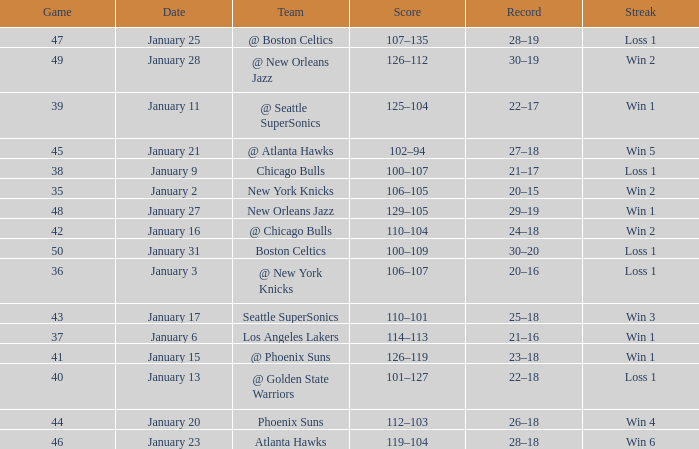What is the Team in Game 38? Chicago Bulls. Write the full table. {'header': ['Game', 'Date', 'Team', 'Score', 'Record', 'Streak'], 'rows': [['47', 'January 25', '@ Boston Celtics', '107–135', '28–19', 'Loss 1'], ['49', 'January 28', '@ New Orleans Jazz', '126–112', '30–19', 'Win 2'], ['39', 'January 11', '@ Seattle SuperSonics', '125–104', '22–17', 'Win 1'], ['45', 'January 21', '@ Atlanta Hawks', '102–94', '27–18', 'Win 5'], ['38', 'January 9', 'Chicago Bulls', '100–107', '21–17', 'Loss 1'], ['35', 'January 2', 'New York Knicks', '106–105', '20–15', 'Win 2'], ['48', 'January 27', 'New Orleans Jazz', '129–105', '29–19', 'Win 1'], ['42', 'January 16', '@ Chicago Bulls', '110–104', '24–18', 'Win 2'], ['50', 'January 31', 'Boston Celtics', '100–109', '30–20', 'Loss 1'], ['36', 'January 3', '@ New York Knicks', '106–107', '20–16', 'Loss 1'], ['43', 'January 17', 'Seattle SuperSonics', '110–101', '25–18', 'Win 3'], ['37', 'January 6', 'Los Angeles Lakers', '114–113', '21–16', 'Win 1'], ['41', 'January 15', '@ Phoenix Suns', '126–119', '23–18', 'Win 1'], ['40', 'January 13', '@ Golden State Warriors', '101–127', '22–18', 'Loss 1'], ['44', 'January 20', 'Phoenix Suns', '112–103', '26–18', 'Win 4'], ['46', 'January 23', 'Atlanta Hawks', '119–104', '28–18', 'Win 6']]} 